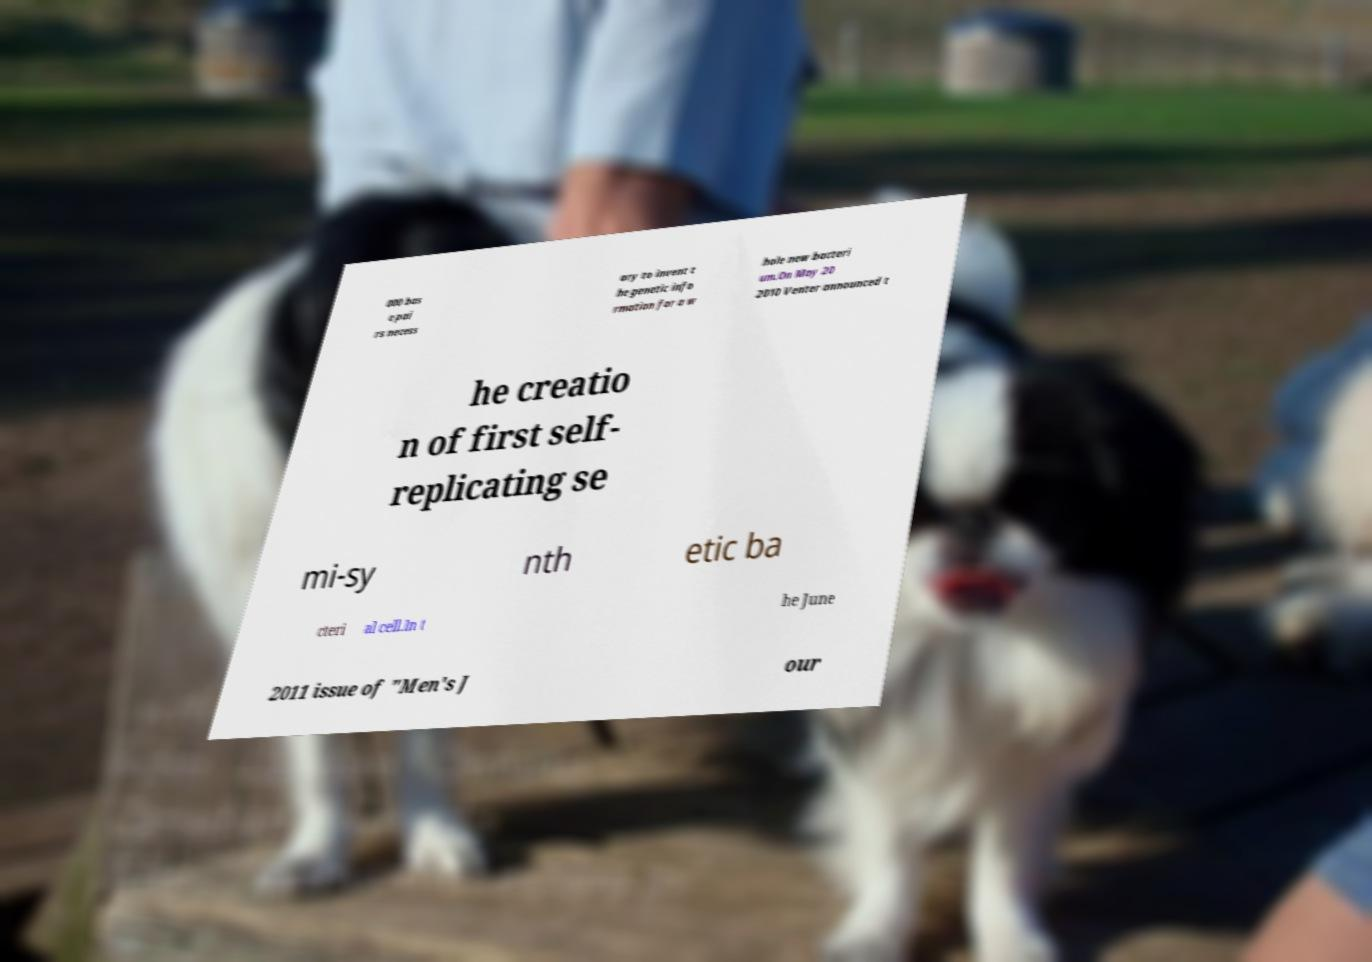Could you assist in decoding the text presented in this image and type it out clearly? 000 bas e pai rs necess ary to invent t he genetic info rmation for a w hole new bacteri um.On May 20 2010 Venter announced t he creatio n of first self- replicating se mi-sy nth etic ba cteri al cell.In t he June 2011 issue of "Men's J our 